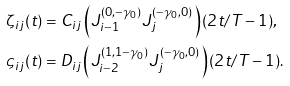Convert formula to latex. <formula><loc_0><loc_0><loc_500><loc_500>\zeta _ { i j } ( t ) & = C _ { i j } \left ( J _ { i - 1 } ^ { ( 0 , - \gamma _ { 0 } ) } J _ { j } ^ { ( - \gamma _ { 0 } , 0 ) } \right ) ( 2 t / T - 1 ) , \\ \varsigma _ { i j } ( t ) & = D _ { i j } \left ( J _ { i - 2 } ^ { ( 1 , 1 - \gamma _ { 0 } ) } J _ { j } ^ { ( - \gamma _ { 0 } , 0 ) } \right ) ( 2 t / T - 1 ) .</formula> 